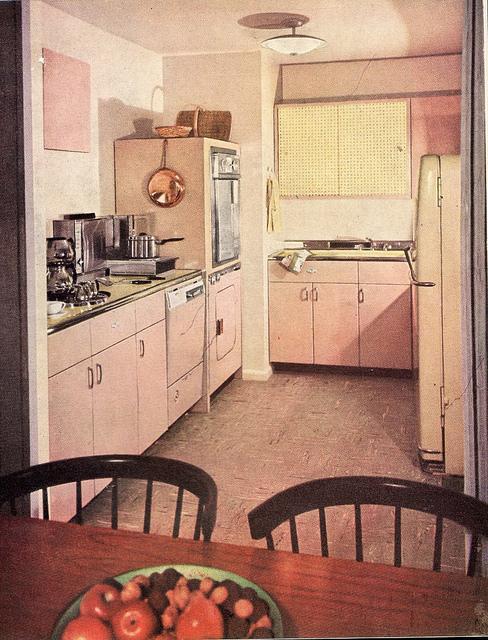How many chairs can be seen?
Give a very brief answer. 2. How many ovens are there?
Give a very brief answer. 3. How many chairs are there?
Give a very brief answer. 2. 